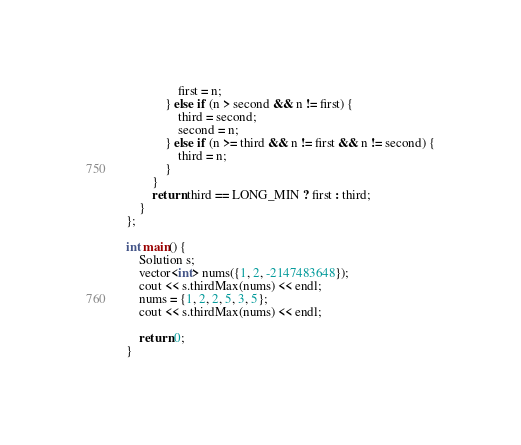<code> <loc_0><loc_0><loc_500><loc_500><_C++_>                first = n;
            } else if (n > second && n != first) {
                third = second;
                second = n;
            } else if (n >= third && n != first && n != second) {
                third = n;
            }
        }
        return third == LONG_MIN ? first : third;
    }
};

int main() {
    Solution s;
    vector<int> nums({1, 2, -2147483648});
    cout << s.thirdMax(nums) << endl;
    nums = {1, 2, 2, 5, 3, 5};
    cout << s.thirdMax(nums) << endl;

    return 0;
}
</code> 